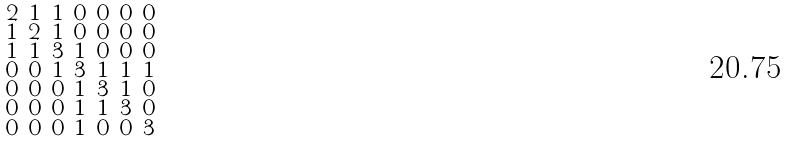<formula> <loc_0><loc_0><loc_500><loc_500>\begin{smallmatrix} 2 & 1 & 1 & 0 & 0 & 0 & 0 \\ 1 & 2 & 1 & 0 & 0 & 0 & 0 \\ 1 & 1 & 3 & 1 & 0 & 0 & 0 \\ 0 & 0 & 1 & 3 & 1 & 1 & 1 \\ 0 & 0 & 0 & 1 & 3 & 1 & 0 \\ 0 & 0 & 0 & 1 & 1 & 3 & 0 \\ 0 & 0 & 0 & 1 & 0 & 0 & 3 \end{smallmatrix}</formula> 